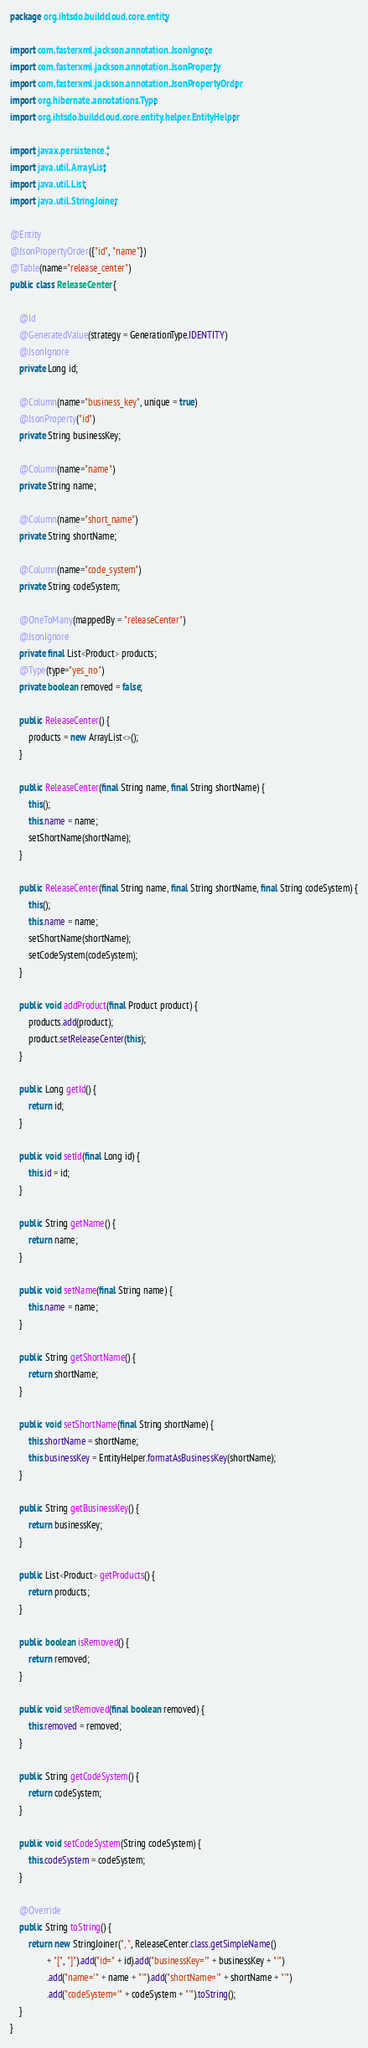Convert code to text. <code><loc_0><loc_0><loc_500><loc_500><_Java_>package org.ihtsdo.buildcloud.core.entity;

import com.fasterxml.jackson.annotation.JsonIgnore;
import com.fasterxml.jackson.annotation.JsonProperty;
import com.fasterxml.jackson.annotation.JsonPropertyOrder;
import org.hibernate.annotations.Type;
import org.ihtsdo.buildcloud.core.entity.helper.EntityHelper;

import javax.persistence.*;
import java.util.ArrayList;
import java.util.List;
import java.util.StringJoiner;

@Entity
@JsonPropertyOrder({"id", "name"})
@Table(name="release_center")
public class ReleaseCenter {

	@Id
	@GeneratedValue(strategy = GenerationType.IDENTITY)
	@JsonIgnore
	private Long id;

	@Column(name="business_key", unique = true)
	@JsonProperty("id")
	private String businessKey;
	
	@Column(name="name")
	private String name;
	
	@Column(name="short_name")
	private String shortName;

	@Column(name="code_system")
	private String codeSystem;

	@OneToMany(mappedBy = "releaseCenter")
	@JsonIgnore
	private final List<Product> products;
	@Type(type="yes_no")
	private boolean removed = false;

	public ReleaseCenter() {
		products = new ArrayList<>();
	}

	public ReleaseCenter(final String name, final String shortName) {
		this();
		this.name = name;
		setShortName(shortName);
	}

	public ReleaseCenter(final String name, final String shortName, final String codeSystem) {
		this();
		this.name = name;
		setShortName(shortName);
		setCodeSystem(codeSystem);
	}

	public void addProduct(final Product product) {
		products.add(product);
		product.setReleaseCenter(this);
	}

	public Long getId() {
		return id;
	}

	public void setId(final Long id) {
		this.id = id;
	}

	public String getName() {
		return name;
	}

	public void setName(final String name) {
		this.name = name;
	}

	public String getShortName() {
		return shortName;
	}

	public void setShortName(final String shortName) {
		this.shortName = shortName;
		this.businessKey = EntityHelper.formatAsBusinessKey(shortName);
	}

	public String getBusinessKey() {
		return businessKey;
	}

	public List<Product> getProducts() {
		return products;
	}

	public boolean isRemoved() {
		return removed;
	}

	public void setRemoved(final boolean removed) {
		this.removed = removed;
	}

	public String getCodeSystem() {
		return codeSystem;
	}

	public void setCodeSystem(String codeSystem) {
		this.codeSystem = codeSystem;
	}

	@Override
	public String toString() {
		return new StringJoiner(", ", ReleaseCenter.class.getSimpleName()
				+ "[", "]").add("id=" + id).add("businessKey='" + businessKey + "'")
				.add("name='" + name + "'").add("shortName='" + shortName + "'")
				.add("codeSystem='" + codeSystem + "'").toString();
	}
}
</code> 